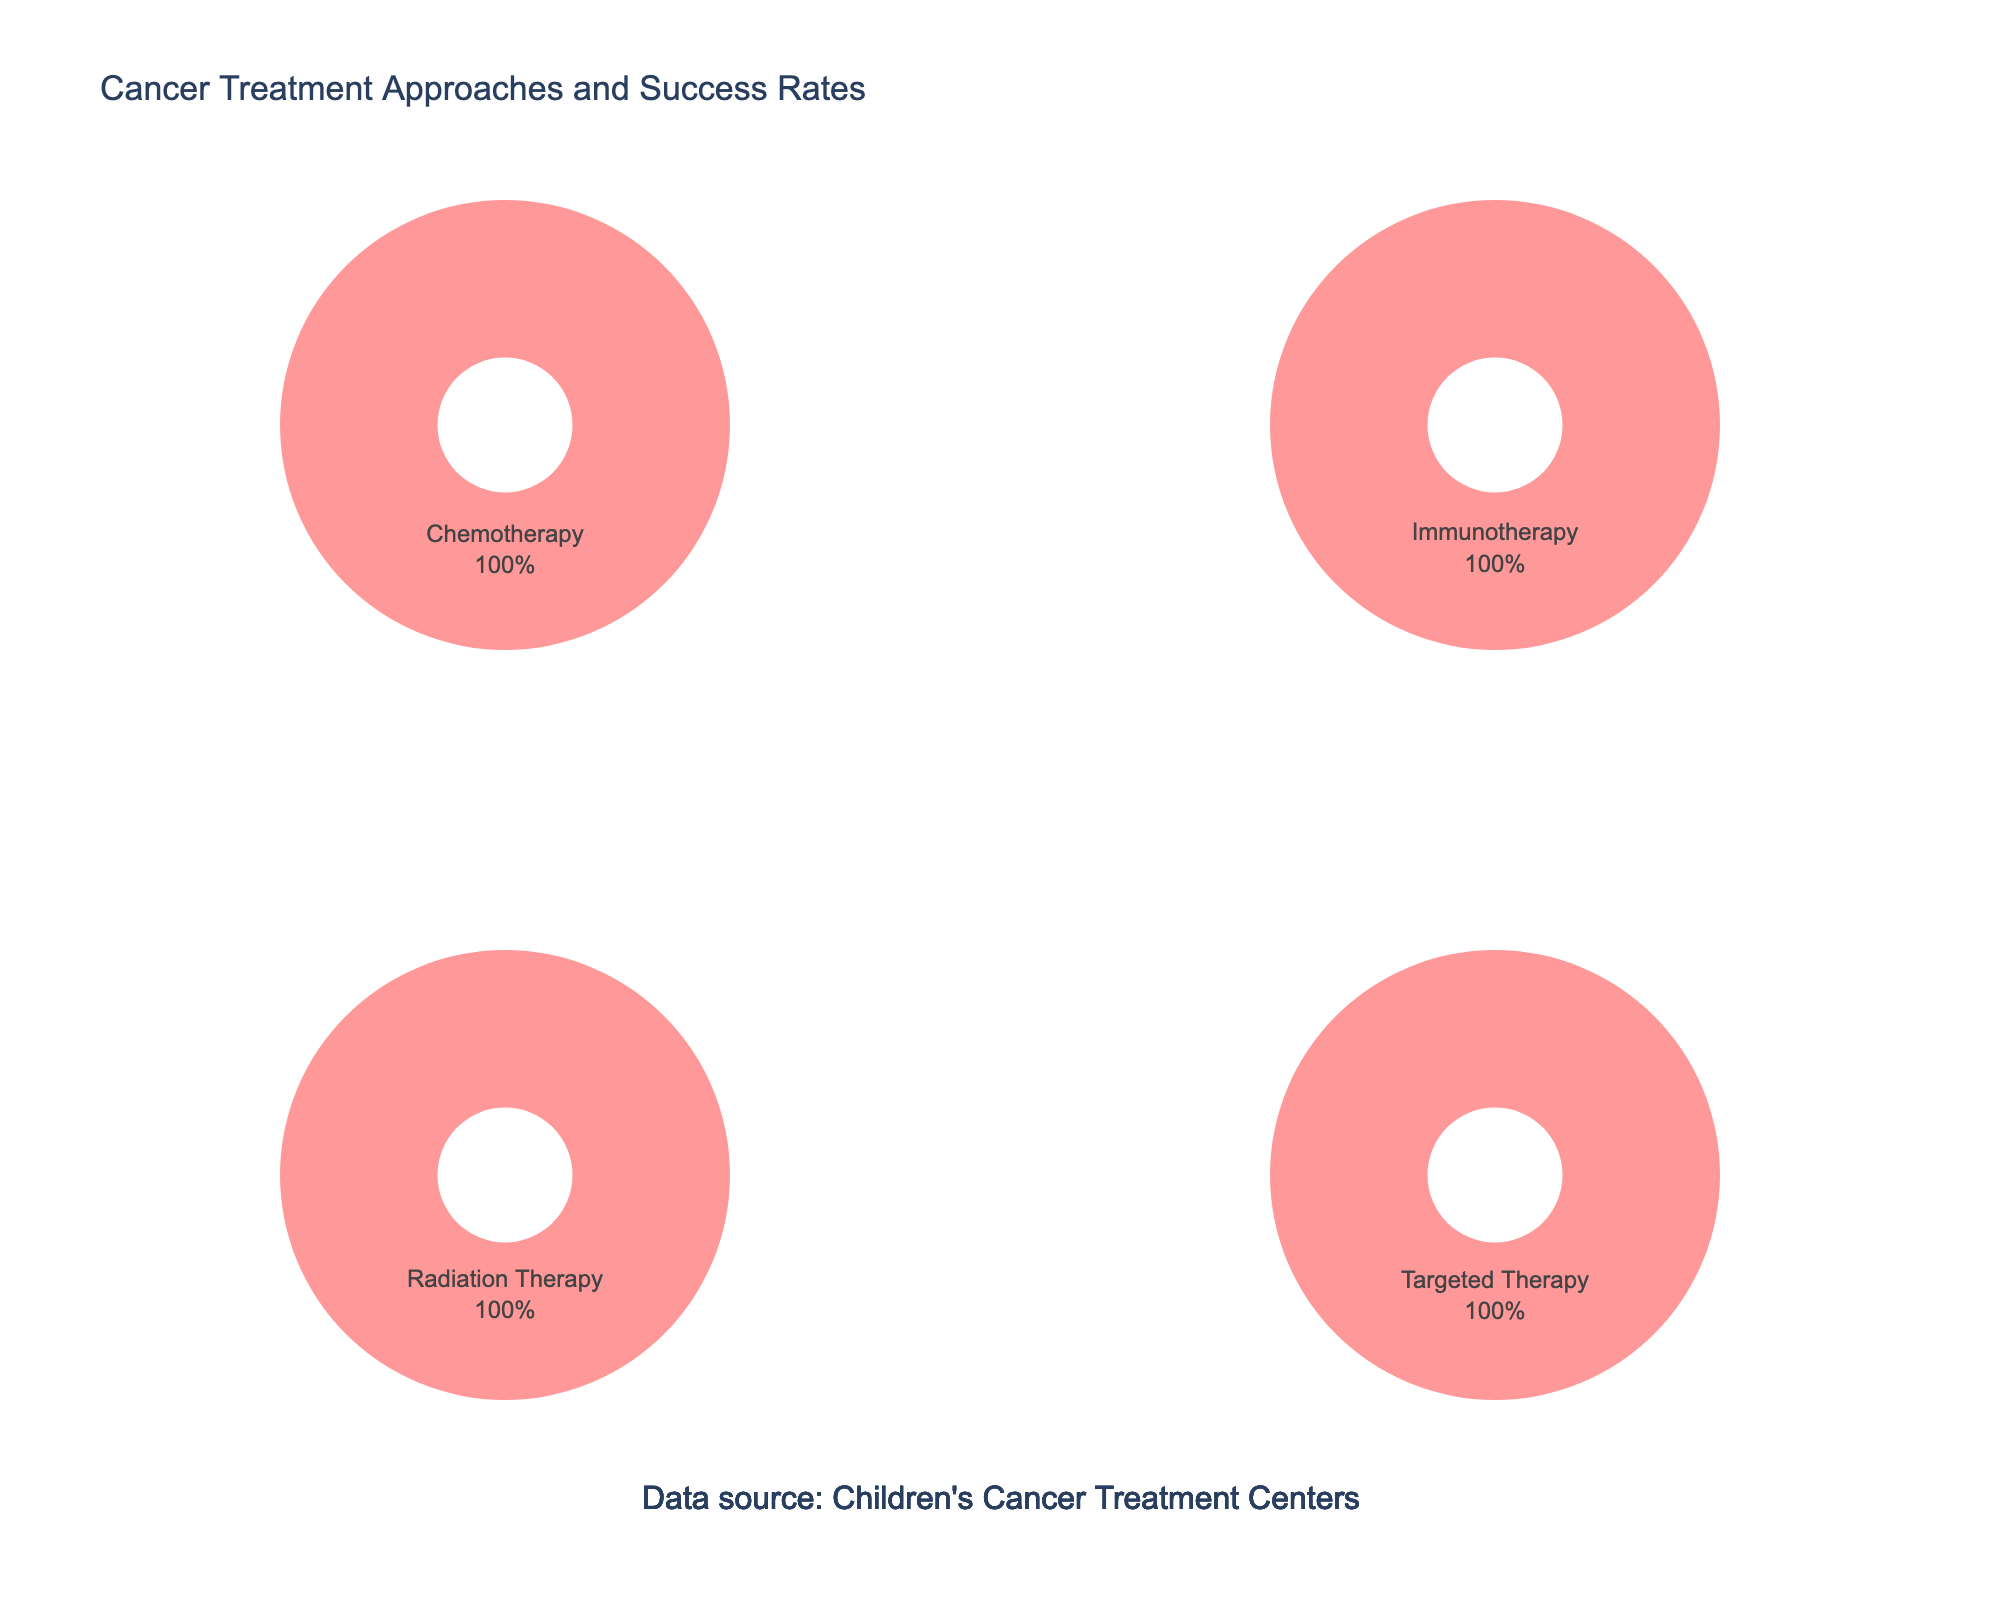How many hospitals are featured in the figure? The subplot titles correspond to the hospitals. There are four subplots with distinct titles.
Answer: 4 What are the colors used in the pie charts? Observing the pie charts, each segment uses one of the four colors: red, blue, green, and orange.
Answer: red, blue, green, and orange Which hospital has the highest success rate for a treatment approach, and what is the success rate? The success rate appears in the pie chart's hover information as part of the value text. By reviewing them, Memorial Sloan Kettering Cancer Center shows the highest success rate of 85%.
Answer: Memorial Sloan Kettering Cancer Center, 85% What's the average number of cases for the treatment approaches represented in the subplot? To find the average number of cases, sum the number of cases of the treatment approaches for all hospitals in the subplot and divide by 4: (523 + 412 + 389 + 356) / 4 = 1680 / 4 = 420.
Answer: 420 How does the average age of patients compare across the hospitals displayed? By checking the values in the 'Average_Age' column used in each pie chart, the ages are 8, 10, 7, and 9 for the four hospitals, respectively. The average can be calculated as (8 + 10 + 7 + 9) / 4 = 34 / 4 = 8.5.
Answer: 8.5 Which hospital has the lowest number of cases for a single treatment approach, and what is the number? Reviewing each pie chart, we note the lowest count per hospital. Cincinnati Children's Hospital has the lowest number of cases (298).
Answer: Cincinnati Children's Hospital, 298 Is the success rate of targeted therapy at Texas Children's Hospital higher or lower than the success rate of chemotherapy at Children's Hospital of Philadelphia? Compare the success rates indicated within the pie charts: 80% for targeted therapy at Texas Children's Hospital and 78% for chemotherapy at Children's Hospital of Philadelphia.
Answer: Higher Which treatment approach is most common at St. Jude Children's Research Hospital? The most common treatment approach can be determined by the largest pie slice. Immunotherapy, indicated largest, is most common at St. Jude.
Answer: Immunotherapy Given the success rates, which treatment approach might be considered least effective, and at which hospital? The figure shows Surgery at Cincinnati Children's Hospital has the lowest success rate at 73%.
Answer: Surgery, Cincinnati Children's Hospital 